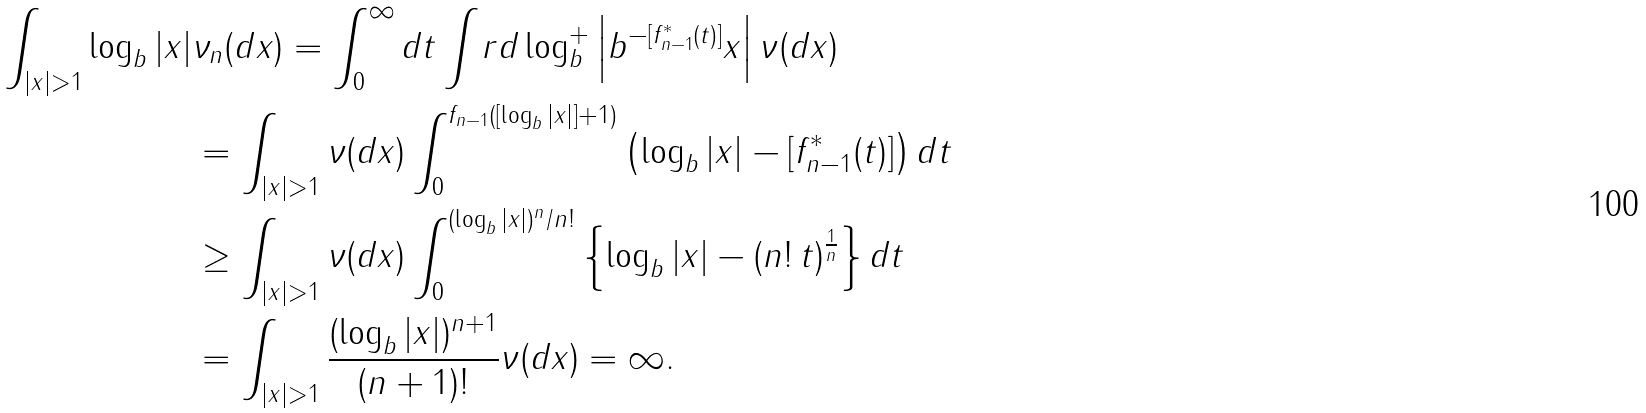<formula> <loc_0><loc_0><loc_500><loc_500>\int _ { | x | > 1 } \log _ { b } | x | & \nu _ { n } ( d x ) = \int _ { 0 } ^ { \infty } d t \int _ { \ } r d \log _ { b } ^ { + } \left | b ^ { - [ f _ { n - 1 } ^ { * } ( t ) ] } x \right | \nu ( d x ) \\ & = \int _ { | x | > 1 } \nu ( d x ) \int _ { 0 } ^ { f _ { n - 1 } ( [ \log _ { b } | x | ] + 1 ) } \left ( \log _ { b } | x | - [ f _ { n - 1 } ^ { * } ( t ) ] \right ) d t \\ & \geq \int _ { | x | > 1 } \nu ( d x ) \int _ { 0 } ^ { ( \log _ { b } | x | ) ^ { n } / n ! } \left \{ \log _ { b } | x | - ( n ! \, t ) ^ { \frac { 1 } { n } } \right \} d t \\ & = \int _ { | x | > 1 } \frac { ( \log _ { b } | x | ) ^ { n + 1 } } { ( n + 1 ) ! } \nu ( d x ) = \infty .</formula> 